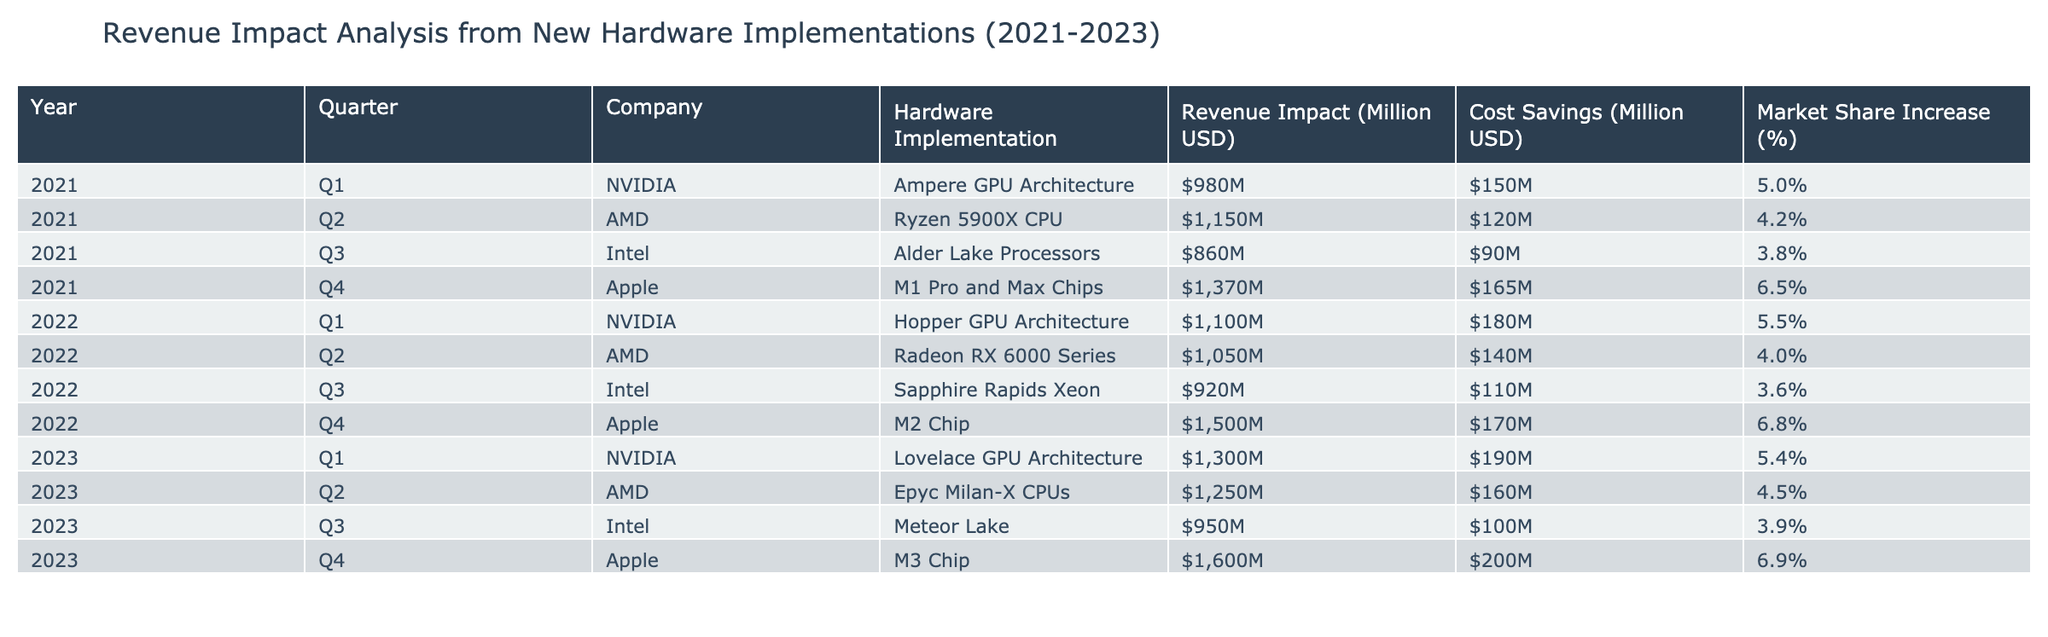What was the highest revenue impact recorded in 2021? In 2021, the revenue impacts were 980, 1150, 860, and 1370 million USD for NVIDIA, AMD, Intel, and Apple respectively. The highest value among these is 1370 million USD from Apple in Q4.
Answer: 1370 million USD Which company had the second highest cost savings in Q2 2023? In Q2 2023, AMD had cost savings of 160 million USD, while NVIDIA had 190 million USD. Thus, AMD is the second highest since it's only behind NVIDIA.
Answer: AMD What is the total revenue impact from Apple’s hardware implementations over the three years? The revenue impacts from Apple (2021-2023) are 1370, 1500, and 1600 million USD. Summing these gives 1370 + 1500 + 1600 = 4470 million USD.
Answer: 4470 million USD Did Intel experience an increase in revenue impact each year from 2021 to 2023? In 2021, Intel had a revenue impact of 860 million USD; in 2022, it decreased slightly to 920 million USD; in 2023, it again decreased to 950 million USD. Therefore, it did not experience a yearly increase.
Answer: No What is the average market share increase for AMD’s hardware implementations over the three years? The market share increases for AMD from 2021 to 2023 are 4.2%, 4%, and 4.5%. To calculate the average: (4.2 + 4 + 4.5) / 3 = 4.23%.
Answer: 4.23% Which quarter in 2022 had the lowest revenue impact and how much was it? The revenue impacts for Intel, AMD, and NVIDIA in 2022 were 920, 1050, and 1100 million USD respectively. The lowest value is 920 million USD from Intel in Q3 2022.
Answer: Q3 2022, 920 million USD What company had the highest market share increase and in which quarter was it? The highest market share increase was 6.9% from Apple in Q4 2023. Thus, Apple is the company with the highest increase.
Answer: Apple, Q4 2023 What was the total cost savings across all companies in 2023? The cost savings for NVIDIA, AMD, Intel, and Apple in 2023 are 190, 160, 100, and 200 million USD respectively. Summing these: 190 + 160 + 100 + 200 = 650 million USD.
Answer: 650 million USD 